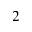<formula> <loc_0><loc_0><loc_500><loc_500>^ { 2 }</formula> 